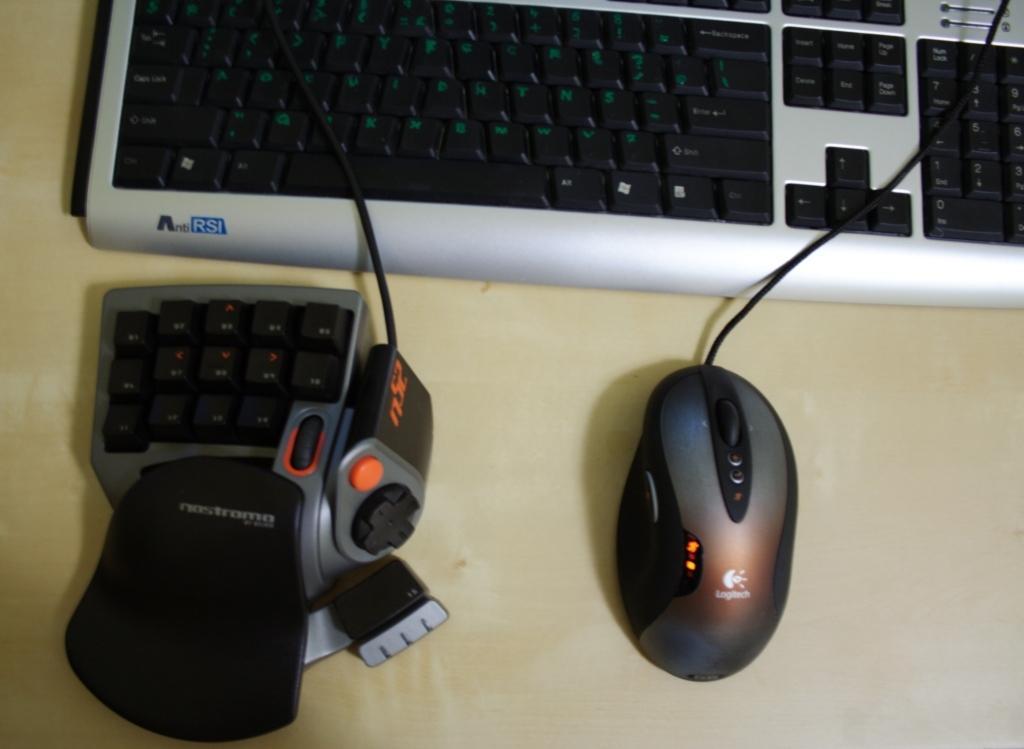Describe this image in one or two sentences. In the picture we can see a desk on it we can see a keyboard, a mouse with a wire, and some separate keypad with buttons. 